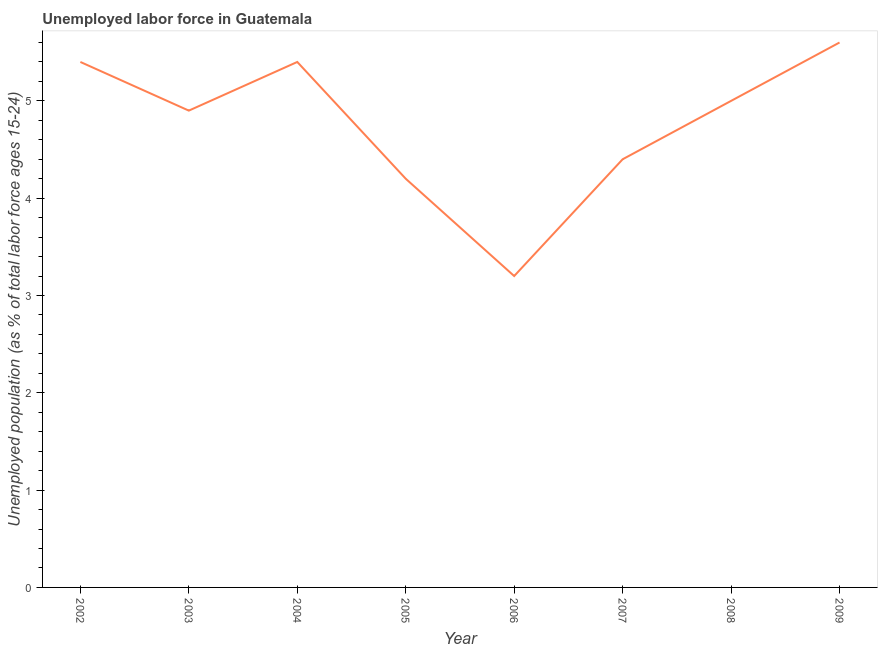What is the total unemployed youth population in 2005?
Provide a short and direct response. 4.2. Across all years, what is the maximum total unemployed youth population?
Provide a short and direct response. 5.6. Across all years, what is the minimum total unemployed youth population?
Offer a terse response. 3.2. What is the sum of the total unemployed youth population?
Keep it short and to the point. 38.1. What is the difference between the total unemployed youth population in 2002 and 2008?
Your answer should be compact. 0.4. What is the average total unemployed youth population per year?
Offer a very short reply. 4.76. What is the median total unemployed youth population?
Your answer should be very brief. 4.95. In how many years, is the total unemployed youth population greater than 5.4 %?
Provide a short and direct response. 3. What is the ratio of the total unemployed youth population in 2003 to that in 2007?
Offer a terse response. 1.11. Is the total unemployed youth population in 2006 less than that in 2007?
Your response must be concise. Yes. Is the difference between the total unemployed youth population in 2002 and 2008 greater than the difference between any two years?
Your answer should be compact. No. What is the difference between the highest and the second highest total unemployed youth population?
Give a very brief answer. 0.2. Is the sum of the total unemployed youth population in 2005 and 2009 greater than the maximum total unemployed youth population across all years?
Your answer should be very brief. Yes. What is the difference between the highest and the lowest total unemployed youth population?
Offer a terse response. 2.4. In how many years, is the total unemployed youth population greater than the average total unemployed youth population taken over all years?
Give a very brief answer. 5. Does the total unemployed youth population monotonically increase over the years?
Your answer should be compact. No. How many years are there in the graph?
Your answer should be compact. 8. Does the graph contain grids?
Provide a short and direct response. No. What is the title of the graph?
Make the answer very short. Unemployed labor force in Guatemala. What is the label or title of the Y-axis?
Your answer should be compact. Unemployed population (as % of total labor force ages 15-24). What is the Unemployed population (as % of total labor force ages 15-24) in 2002?
Ensure brevity in your answer.  5.4. What is the Unemployed population (as % of total labor force ages 15-24) of 2003?
Keep it short and to the point. 4.9. What is the Unemployed population (as % of total labor force ages 15-24) of 2004?
Give a very brief answer. 5.4. What is the Unemployed population (as % of total labor force ages 15-24) of 2005?
Your answer should be compact. 4.2. What is the Unemployed population (as % of total labor force ages 15-24) of 2006?
Provide a short and direct response. 3.2. What is the Unemployed population (as % of total labor force ages 15-24) of 2007?
Provide a succinct answer. 4.4. What is the Unemployed population (as % of total labor force ages 15-24) in 2009?
Make the answer very short. 5.6. What is the difference between the Unemployed population (as % of total labor force ages 15-24) in 2002 and 2003?
Provide a short and direct response. 0.5. What is the difference between the Unemployed population (as % of total labor force ages 15-24) in 2002 and 2005?
Offer a terse response. 1.2. What is the difference between the Unemployed population (as % of total labor force ages 15-24) in 2002 and 2006?
Make the answer very short. 2.2. What is the difference between the Unemployed population (as % of total labor force ages 15-24) in 2002 and 2009?
Provide a short and direct response. -0.2. What is the difference between the Unemployed population (as % of total labor force ages 15-24) in 2003 and 2006?
Provide a short and direct response. 1.7. What is the difference between the Unemployed population (as % of total labor force ages 15-24) in 2004 and 2007?
Your response must be concise. 1. What is the difference between the Unemployed population (as % of total labor force ages 15-24) in 2004 and 2009?
Ensure brevity in your answer.  -0.2. What is the difference between the Unemployed population (as % of total labor force ages 15-24) in 2005 and 2006?
Provide a short and direct response. 1. What is the difference between the Unemployed population (as % of total labor force ages 15-24) in 2006 and 2007?
Your answer should be very brief. -1.2. What is the difference between the Unemployed population (as % of total labor force ages 15-24) in 2006 and 2008?
Keep it short and to the point. -1.8. What is the difference between the Unemployed population (as % of total labor force ages 15-24) in 2008 and 2009?
Your response must be concise. -0.6. What is the ratio of the Unemployed population (as % of total labor force ages 15-24) in 2002 to that in 2003?
Your response must be concise. 1.1. What is the ratio of the Unemployed population (as % of total labor force ages 15-24) in 2002 to that in 2005?
Your answer should be very brief. 1.29. What is the ratio of the Unemployed population (as % of total labor force ages 15-24) in 2002 to that in 2006?
Give a very brief answer. 1.69. What is the ratio of the Unemployed population (as % of total labor force ages 15-24) in 2002 to that in 2007?
Offer a very short reply. 1.23. What is the ratio of the Unemployed population (as % of total labor force ages 15-24) in 2002 to that in 2009?
Your answer should be very brief. 0.96. What is the ratio of the Unemployed population (as % of total labor force ages 15-24) in 2003 to that in 2004?
Give a very brief answer. 0.91. What is the ratio of the Unemployed population (as % of total labor force ages 15-24) in 2003 to that in 2005?
Offer a very short reply. 1.17. What is the ratio of the Unemployed population (as % of total labor force ages 15-24) in 2003 to that in 2006?
Offer a terse response. 1.53. What is the ratio of the Unemployed population (as % of total labor force ages 15-24) in 2003 to that in 2007?
Offer a terse response. 1.11. What is the ratio of the Unemployed population (as % of total labor force ages 15-24) in 2004 to that in 2005?
Your response must be concise. 1.29. What is the ratio of the Unemployed population (as % of total labor force ages 15-24) in 2004 to that in 2006?
Provide a succinct answer. 1.69. What is the ratio of the Unemployed population (as % of total labor force ages 15-24) in 2004 to that in 2007?
Your response must be concise. 1.23. What is the ratio of the Unemployed population (as % of total labor force ages 15-24) in 2005 to that in 2006?
Offer a very short reply. 1.31. What is the ratio of the Unemployed population (as % of total labor force ages 15-24) in 2005 to that in 2007?
Provide a short and direct response. 0.95. What is the ratio of the Unemployed population (as % of total labor force ages 15-24) in 2005 to that in 2008?
Offer a very short reply. 0.84. What is the ratio of the Unemployed population (as % of total labor force ages 15-24) in 2005 to that in 2009?
Provide a succinct answer. 0.75. What is the ratio of the Unemployed population (as % of total labor force ages 15-24) in 2006 to that in 2007?
Provide a short and direct response. 0.73. What is the ratio of the Unemployed population (as % of total labor force ages 15-24) in 2006 to that in 2008?
Offer a terse response. 0.64. What is the ratio of the Unemployed population (as % of total labor force ages 15-24) in 2006 to that in 2009?
Offer a terse response. 0.57. What is the ratio of the Unemployed population (as % of total labor force ages 15-24) in 2007 to that in 2008?
Make the answer very short. 0.88. What is the ratio of the Unemployed population (as % of total labor force ages 15-24) in 2007 to that in 2009?
Ensure brevity in your answer.  0.79. What is the ratio of the Unemployed population (as % of total labor force ages 15-24) in 2008 to that in 2009?
Ensure brevity in your answer.  0.89. 